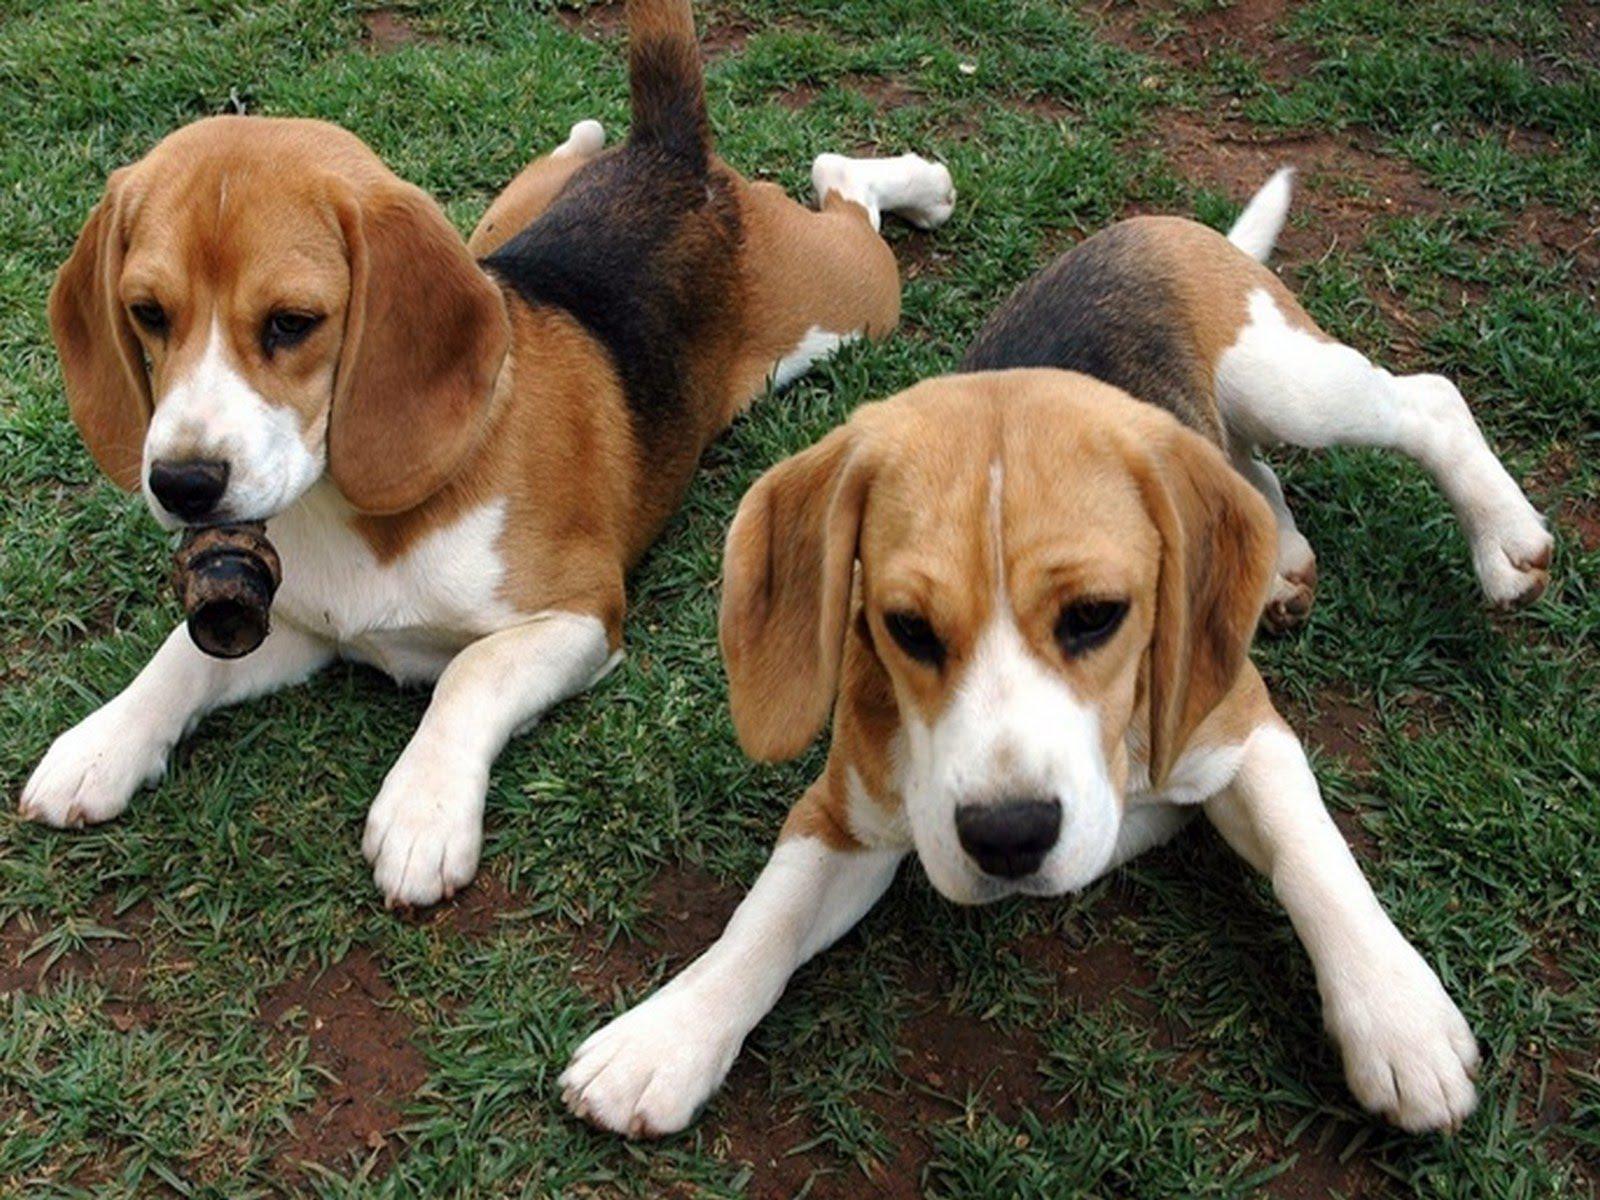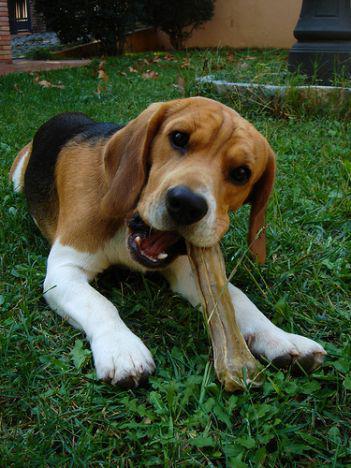The first image is the image on the left, the second image is the image on the right. For the images displayed, is the sentence "All the dogs are lying down." factually correct? Answer yes or no. Yes. 